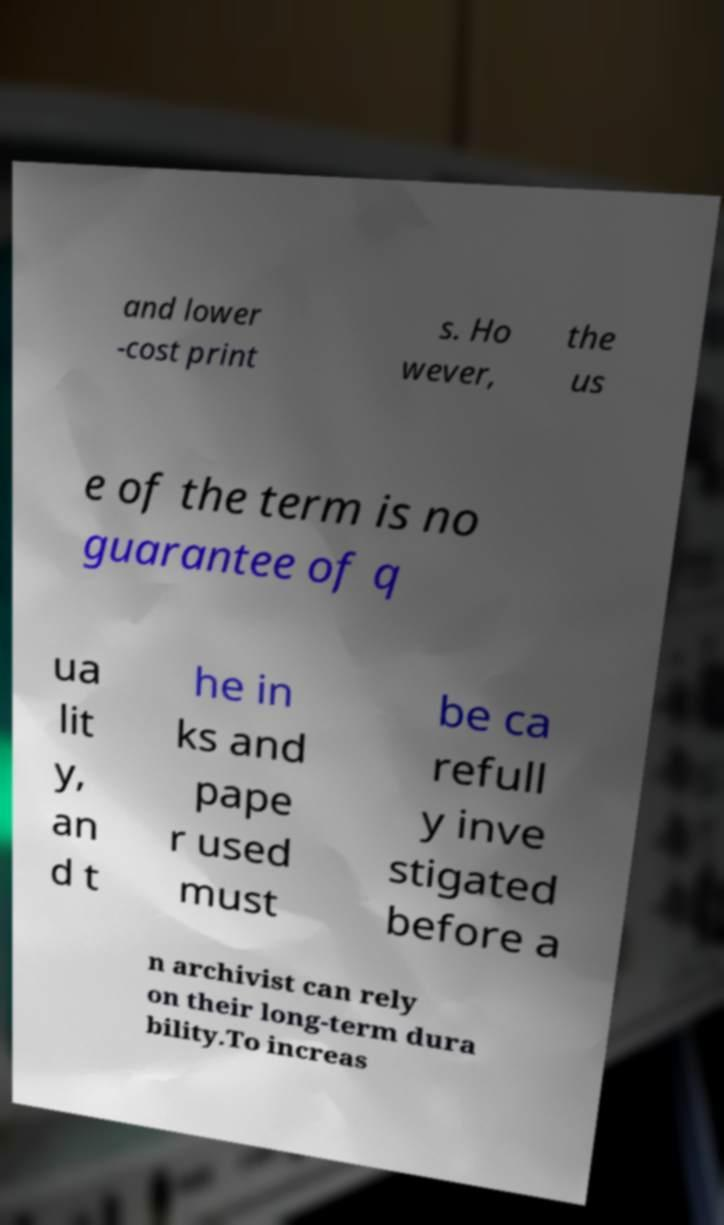I need the written content from this picture converted into text. Can you do that? and lower -cost print s. Ho wever, the us e of the term is no guarantee of q ua lit y, an d t he in ks and pape r used must be ca refull y inve stigated before a n archivist can rely on their long-term dura bility.To increas 